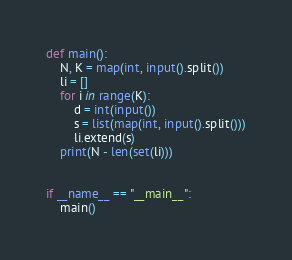Convert code to text. <code><loc_0><loc_0><loc_500><loc_500><_Python_>def main():
    N, K = map(int, input().split())
    li = []
    for i in range(K):
        d = int(input())
        s = list(map(int, input().split()))
        li.extend(s)
    print(N - len(set(li)))


if __name__ == "__main__":
    main()</code> 